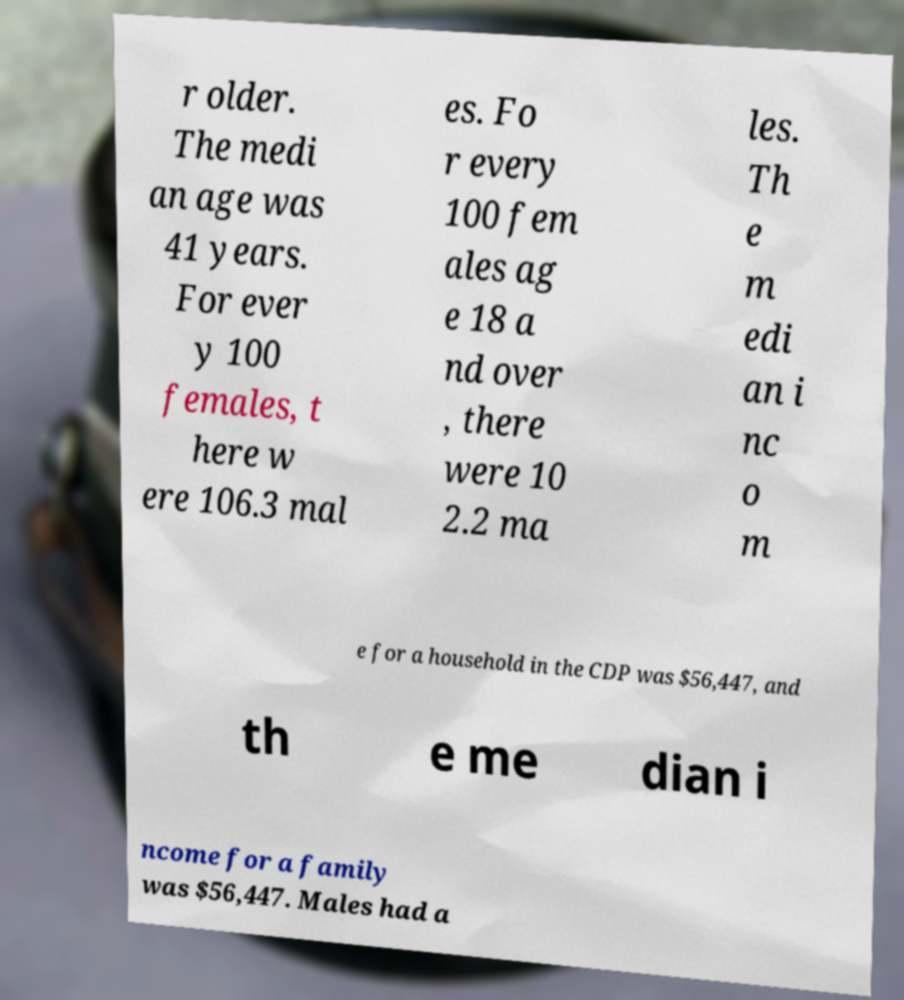What messages or text are displayed in this image? I need them in a readable, typed format. r older. The medi an age was 41 years. For ever y 100 females, t here w ere 106.3 mal es. Fo r every 100 fem ales ag e 18 a nd over , there were 10 2.2 ma les. Th e m edi an i nc o m e for a household in the CDP was $56,447, and th e me dian i ncome for a family was $56,447. Males had a 